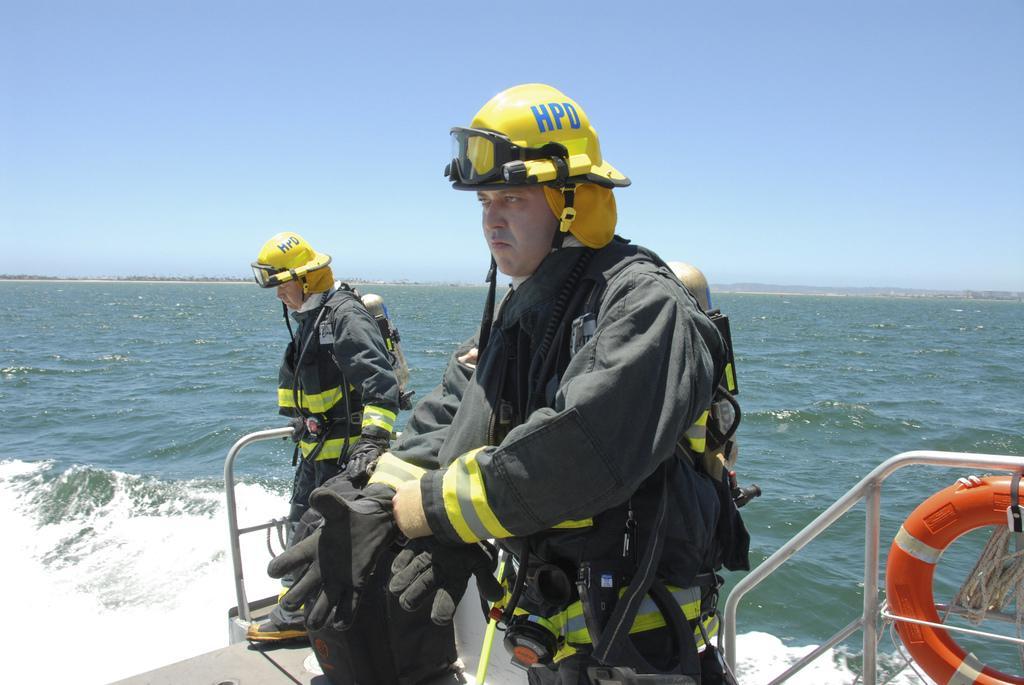Could you give a brief overview of what you see in this image? In this picture we can see two men wore jackets, gloves, helmets and standing on a boat, swim tube and this boat is on water and in the background we can see the sky. 